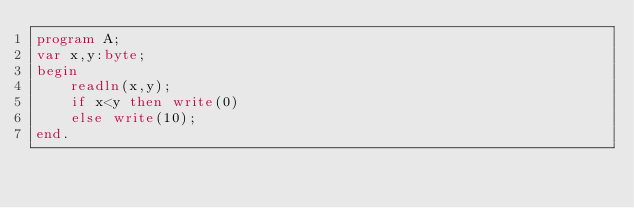Convert code to text. <code><loc_0><loc_0><loc_500><loc_500><_Pascal_>program A;
var x,y:byte;
begin
    readln(x,y);
    if x<y then write(0)
    else write(10);
end.</code> 